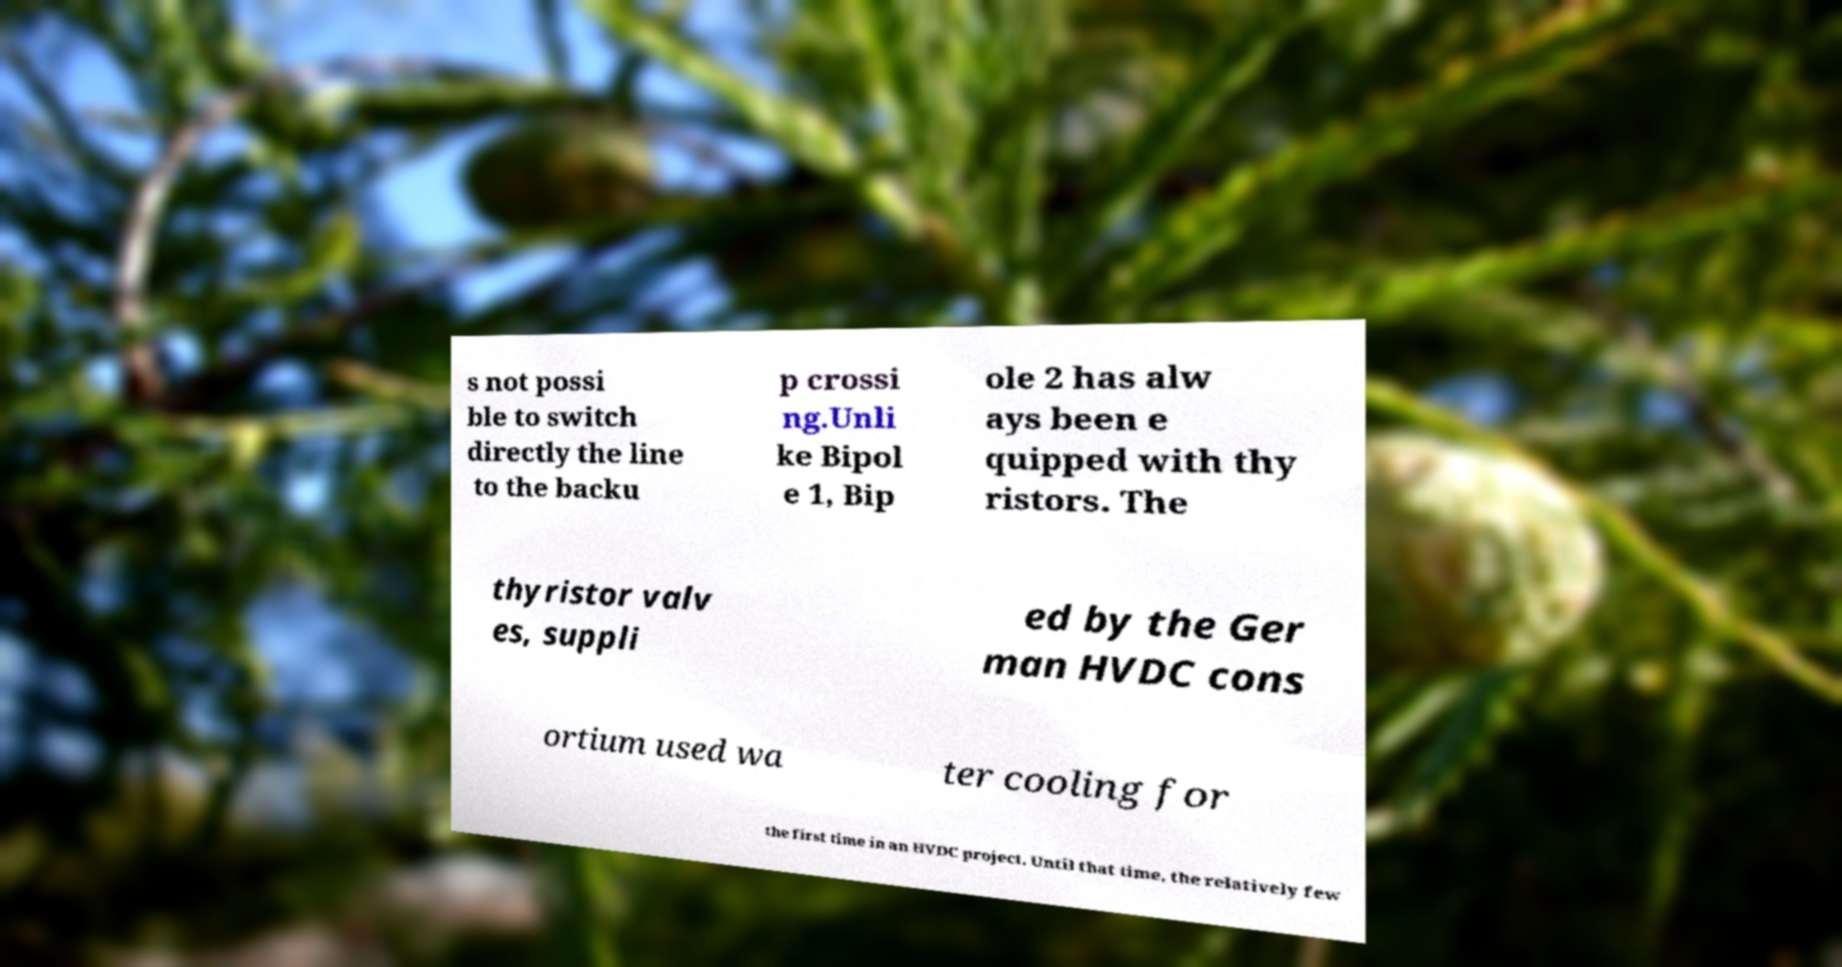There's text embedded in this image that I need extracted. Can you transcribe it verbatim? s not possi ble to switch directly the line to the backu p crossi ng.Unli ke Bipol e 1, Bip ole 2 has alw ays been e quipped with thy ristors. The thyristor valv es, suppli ed by the Ger man HVDC cons ortium used wa ter cooling for the first time in an HVDC project. Until that time, the relatively few 